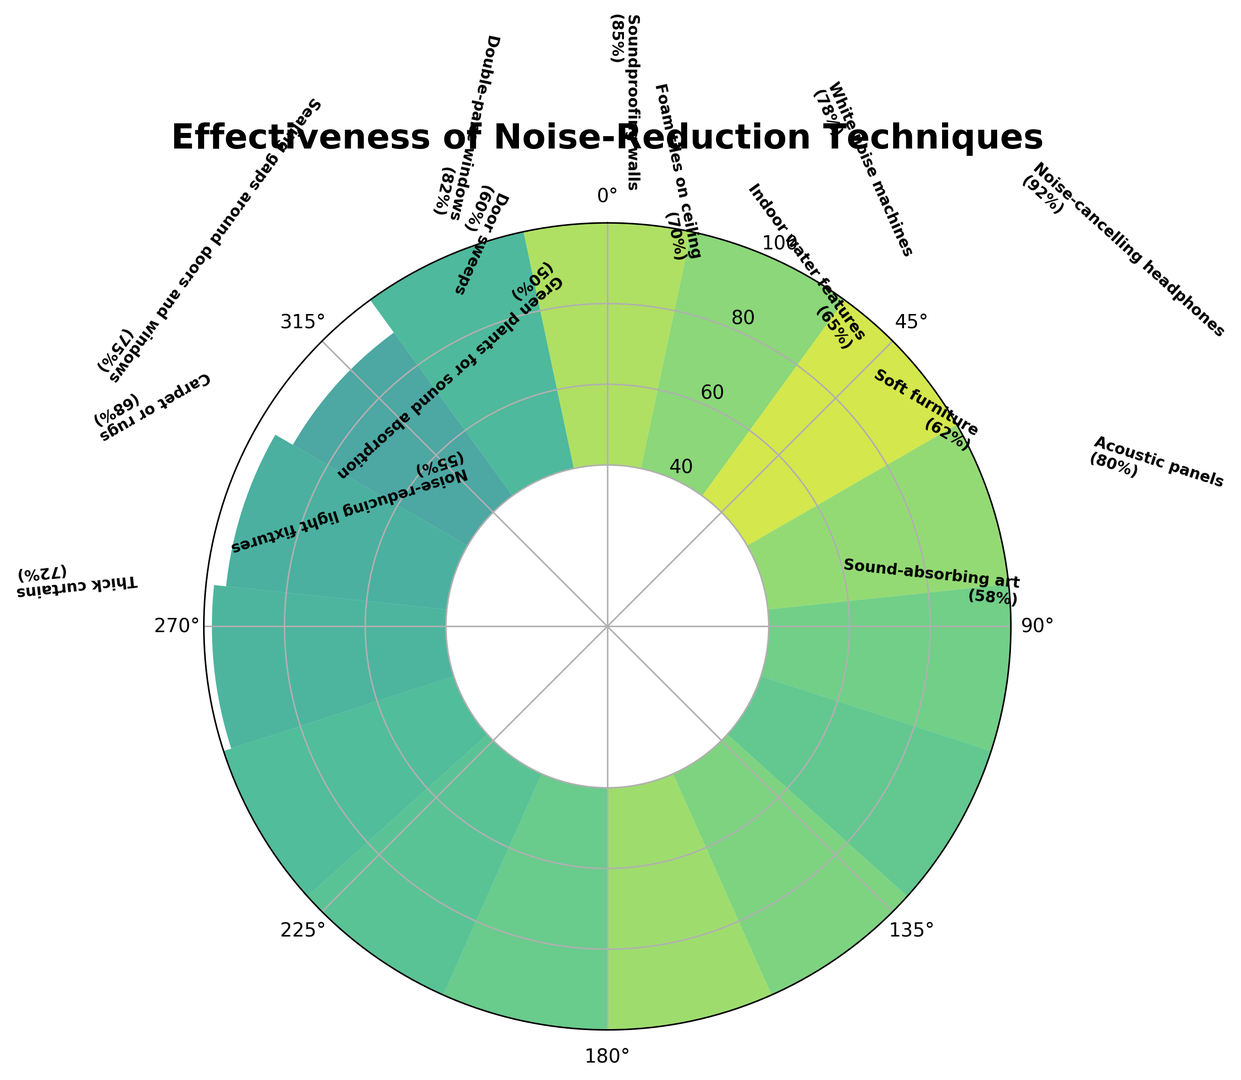What is the most effective noise-reduction technique according to the chart? From the visual representation, we can determine that the tallest bar represents the most effective technique. The bar corresponding to Noise-cancelling headphones reaches the highest point, labeled with 92%.
Answer: Noise-cancelling headphones Which noise-reduction technique is the least effective? By observing the shortest bar in the plot, we can identify the least effective technique. The smallest bar corresponds to Green plants for sound absorption, with an effectiveness rating of 50%.
Answer: Green plants for sound absorption How much more effective are Noise-cancelling headphones compared to Indoor water features? To find the difference, subtract the effectiveness rating of Indoor water features from that of Noise-cancelling headphones (92% - 65%).
Answer: 27% What is the average effectiveness of Soundproofing walls, White noise machines, and Acoustic panels? First, sum the effectiveness of the three techniques: 85 + 78 + 80 = 243. Then, divide the total by 3 to find the average: 243 / 3.
Answer: 81 Which technique has an effectiveness rating closest to 75%? By scanning the labels, we see that Sealing gaps around doors and windows has an effectiveness rating of 75%, which matches exactly.
Answer: Sealing gaps around doors and windows Are Thick curtains more effective than Foam tiles on the ceiling? By comparing the heights of their respective bars, Thick curtains have an effectiveness of 72%, and Foam tiles on the ceiling have 70%. Since 72% is greater than 70%, Thick curtains are more effective.
Answer: Yes How many techniques have an effectiveness rating above 80%? By counting the bars that surpass the 80% effectiveness mark, we identify Soundproofing walls (85%), Noise-cancelling headphones (92%), Double-pane windows (82%). There are 3 such techniques.
Answer: 3 Does the plot suggest that Acoustic panels are more effective than Carpet or rugs? By visually comparing the height of the bars for these two techniques, Acoustic panels (80%) have a higher rating than Carpet or rugs (68%).
Answer: Yes What is the total effectiveness score for the techniques with the lowest and highest ratings combined? The technique with the lowest rating is Green plants for sound absorption (50%), and the one with the highest rating is Noise-cancelling headphones (92%). Add these two together: 50 + 92.
Answer: 142 